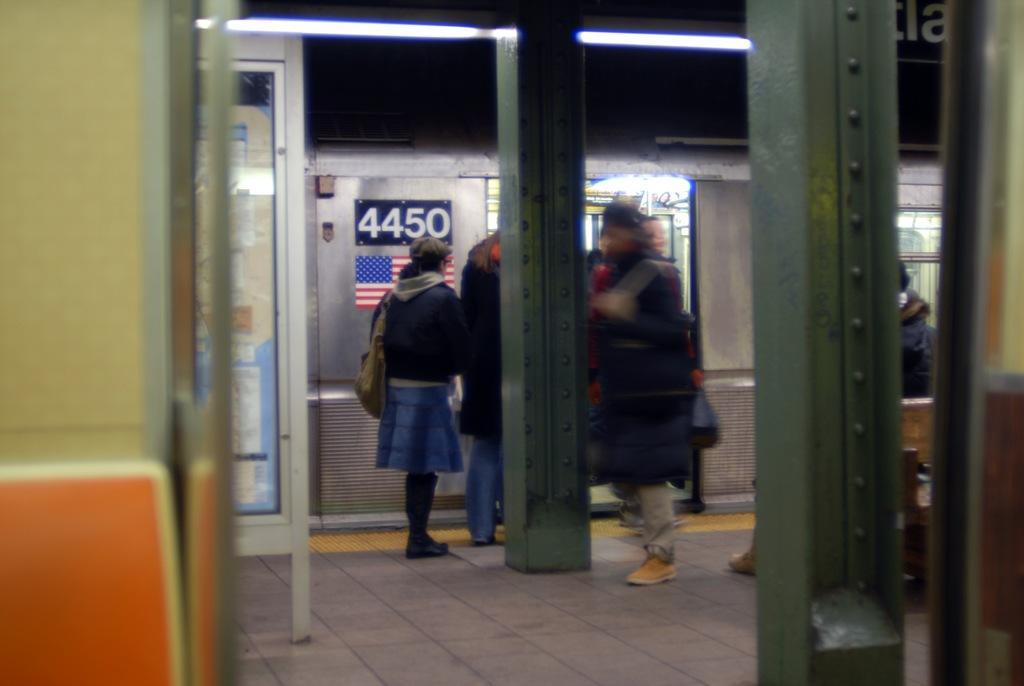Describe this image in one or two sentences. In this image I can see iron beams and I can see a train visible in the middle , in front of the train I can see some persons , on the train I can see a text. 